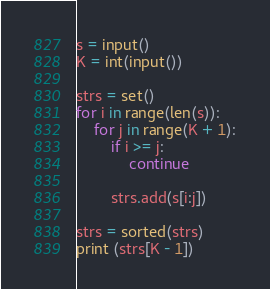<code> <loc_0><loc_0><loc_500><loc_500><_Python_>s = input()
K = int(input())

strs = set()
for i in range(len(s)):
    for j in range(K + 1):
        if i >= j:
            continue

        strs.add(s[i:j])

strs = sorted(strs)
print (strs[K - 1])</code> 